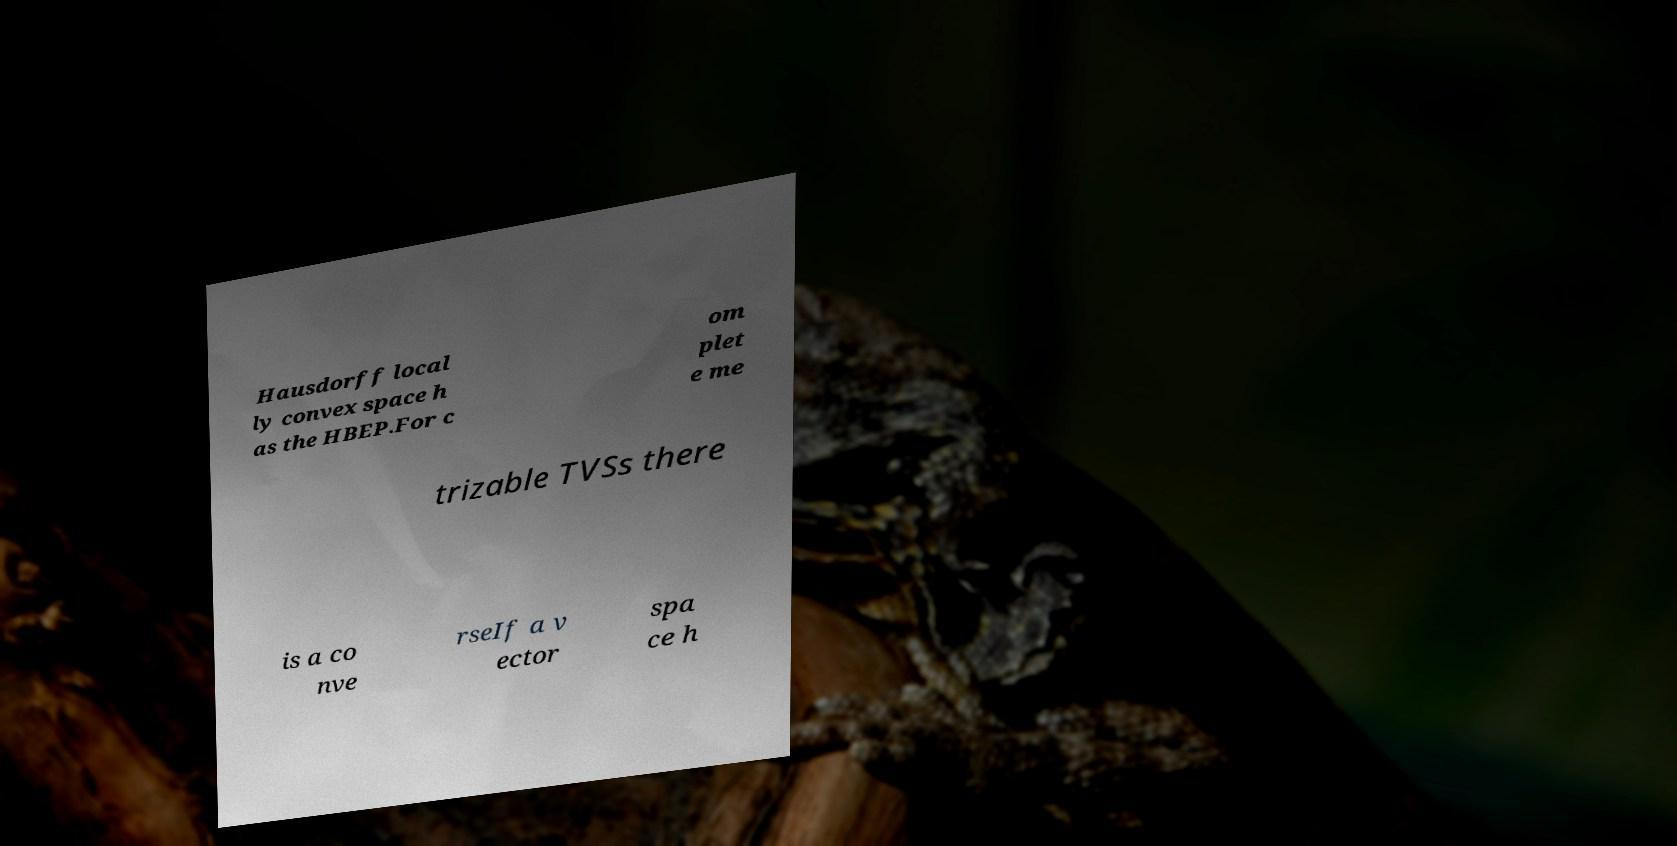There's text embedded in this image that I need extracted. Can you transcribe it verbatim? Hausdorff local ly convex space h as the HBEP.For c om plet e me trizable TVSs there is a co nve rseIf a v ector spa ce h 